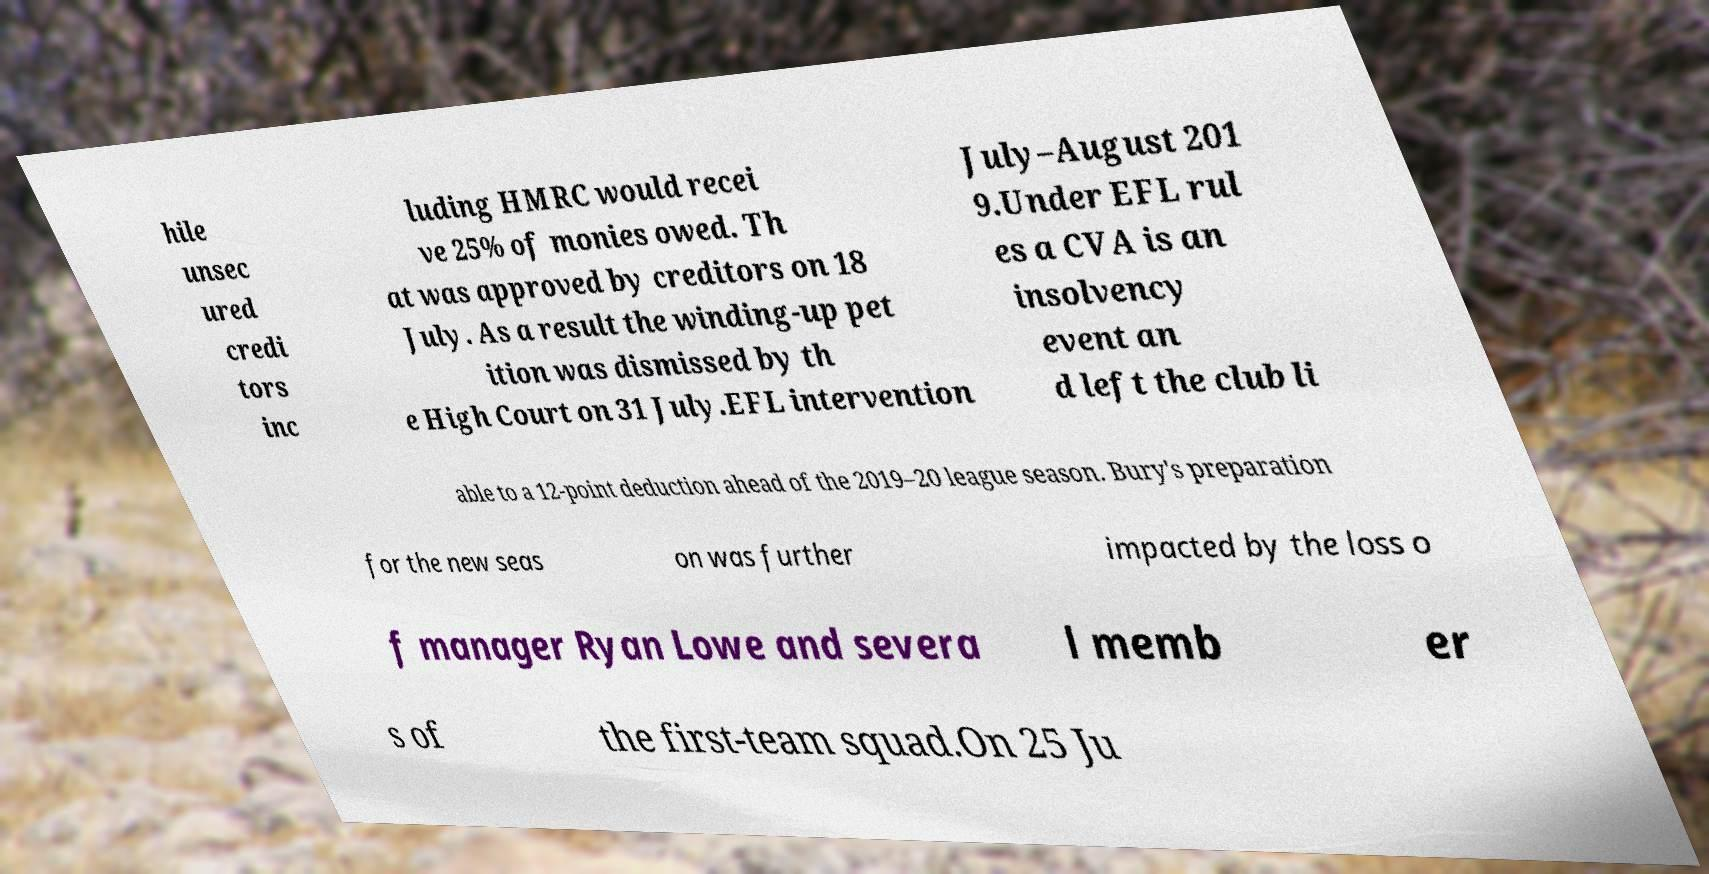Please identify and transcribe the text found in this image. hile unsec ured credi tors inc luding HMRC would recei ve 25% of monies owed. Th at was approved by creditors on 18 July. As a result the winding-up pet ition was dismissed by th e High Court on 31 July.EFL intervention July–August 201 9.Under EFL rul es a CVA is an insolvency event an d left the club li able to a 12-point deduction ahead of the 2019–20 league season. Bury's preparation for the new seas on was further impacted by the loss o f manager Ryan Lowe and severa l memb er s of the first-team squad.On 25 Ju 